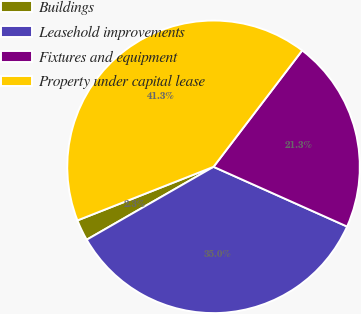Convert chart to OTSL. <chart><loc_0><loc_0><loc_500><loc_500><pie_chart><fcel>Buildings<fcel>Leasehold improvements<fcel>Fixtures and equipment<fcel>Property under capital lease<nl><fcel>2.33%<fcel>35.0%<fcel>21.33%<fcel>41.33%<nl></chart> 